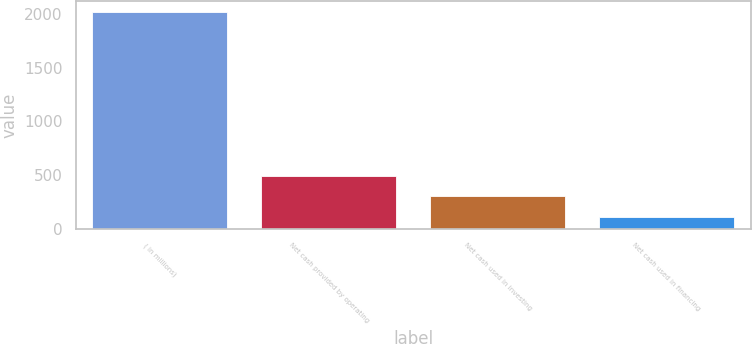Convert chart. <chart><loc_0><loc_0><loc_500><loc_500><bar_chart><fcel>( in millions)<fcel>Net cash provided by operating<fcel>Net cash used in investing<fcel>Net cash used in financing<nl><fcel>2016<fcel>494.32<fcel>304.11<fcel>113.9<nl></chart> 